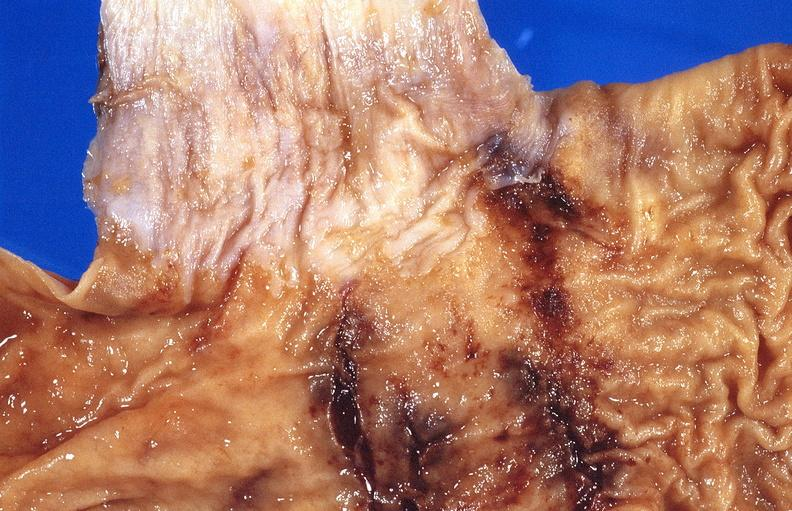where does this belong to?
Answer the question using a single word or phrase. Gastrointestinal system 